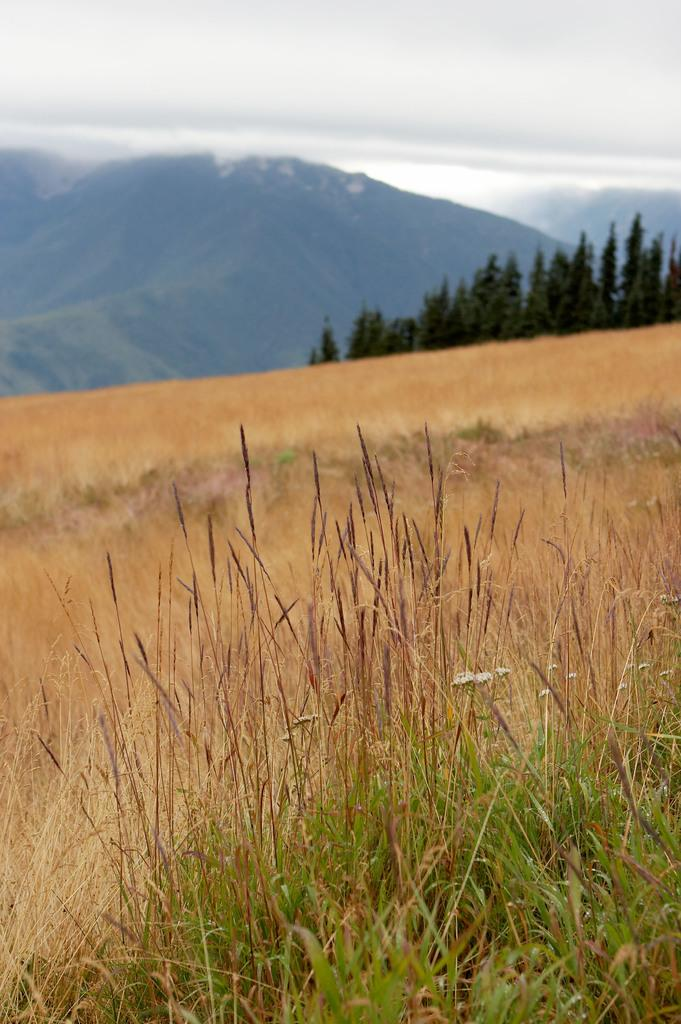What type of vegetation is present in the image? There is grass in the image. What other natural elements can be seen in the image? There are trees and a mountain visible in the image. What is visible in the sky in the image? The sky is visible in the image. What type of cap is the mountain wearing in the image? There is no cap present on the mountain in the image. What value does the flower in the image represent? There is no flower present in the image. 